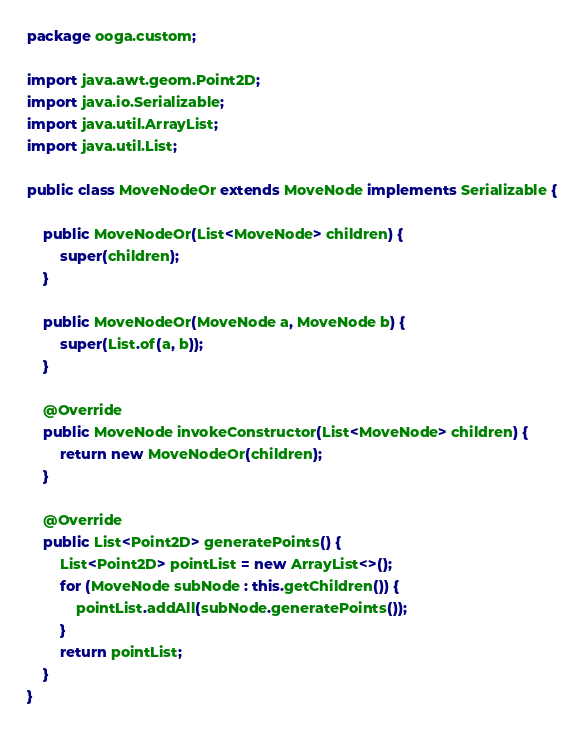Convert code to text. <code><loc_0><loc_0><loc_500><loc_500><_Java_>package ooga.custom;

import java.awt.geom.Point2D;
import java.io.Serializable;
import java.util.ArrayList;
import java.util.List;

public class MoveNodeOr extends MoveNode implements Serializable {

    public MoveNodeOr(List<MoveNode> children) {
        super(children);
    }

    public MoveNodeOr(MoveNode a, MoveNode b) {
        super(List.of(a, b));
    }

    @Override
    public MoveNode invokeConstructor(List<MoveNode> children) {
        return new MoveNodeOr(children);
    }

    @Override
    public List<Point2D> generatePoints() {
        List<Point2D> pointList = new ArrayList<>();
        for (MoveNode subNode : this.getChildren()) {
            pointList.addAll(subNode.generatePoints());
        }
        return pointList;
    }
}
</code> 